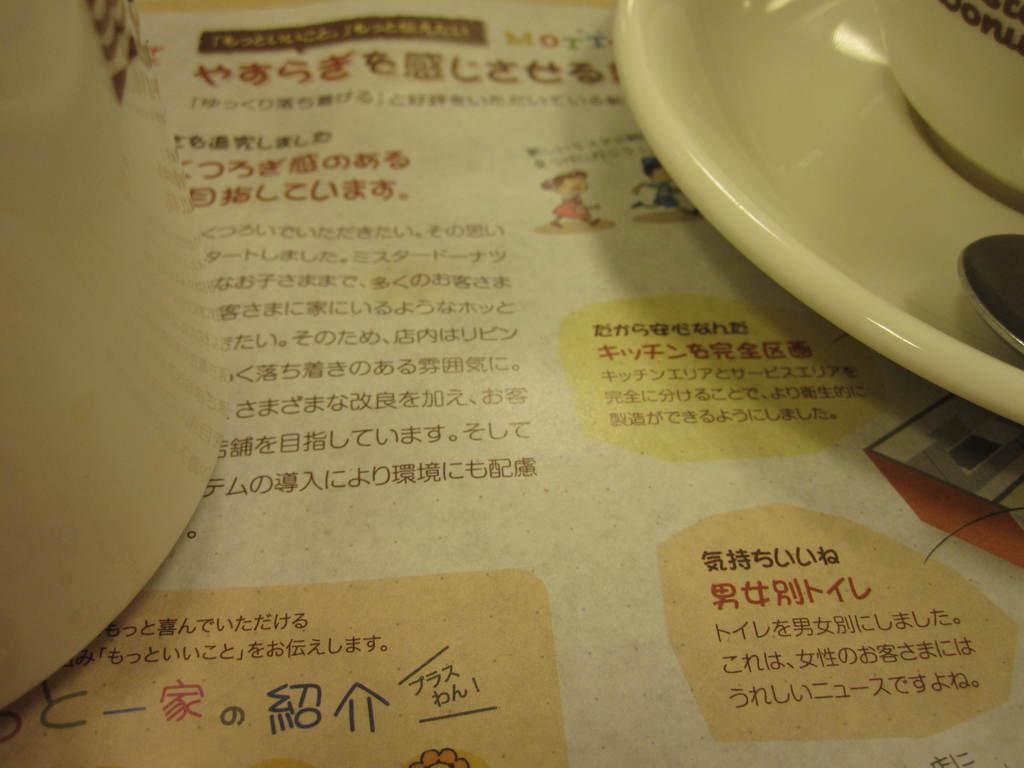Please provide a concise description of this image. In the image there is a paper with few images and there is something written on it. In the top right corner of the image there is a saucer, spoon and also there is a cup. On the left side of the image there is a white color object. 